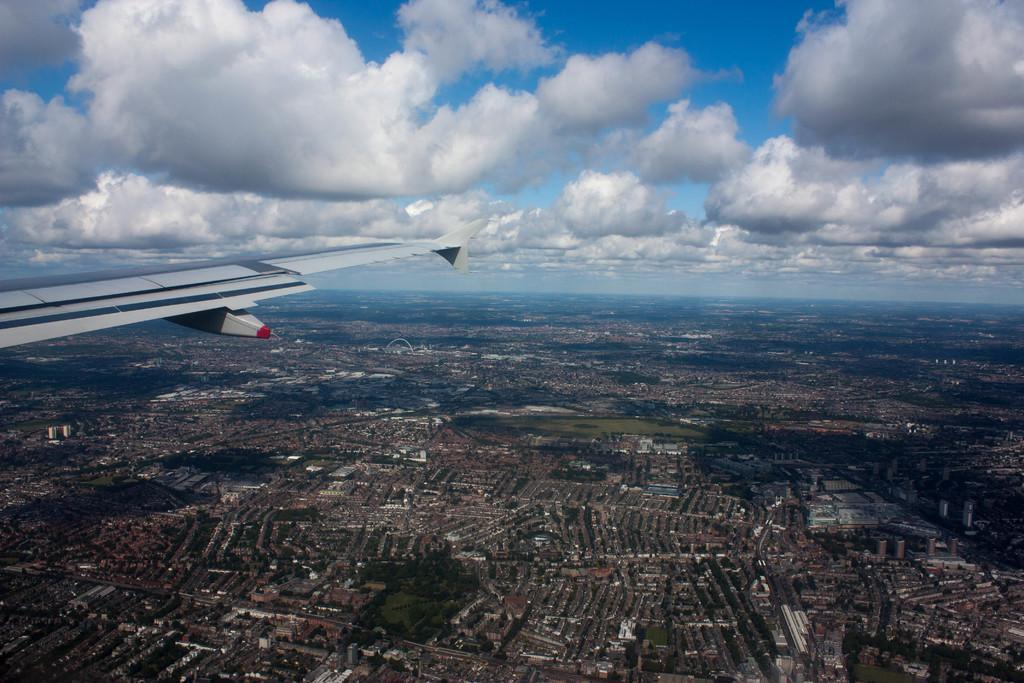How would you summarize this image in a sentence or two? In this picture there is a view of the city from the plane window. Beside there is a white color plane wing. In the bottom side of the image there are many building in the ground. 